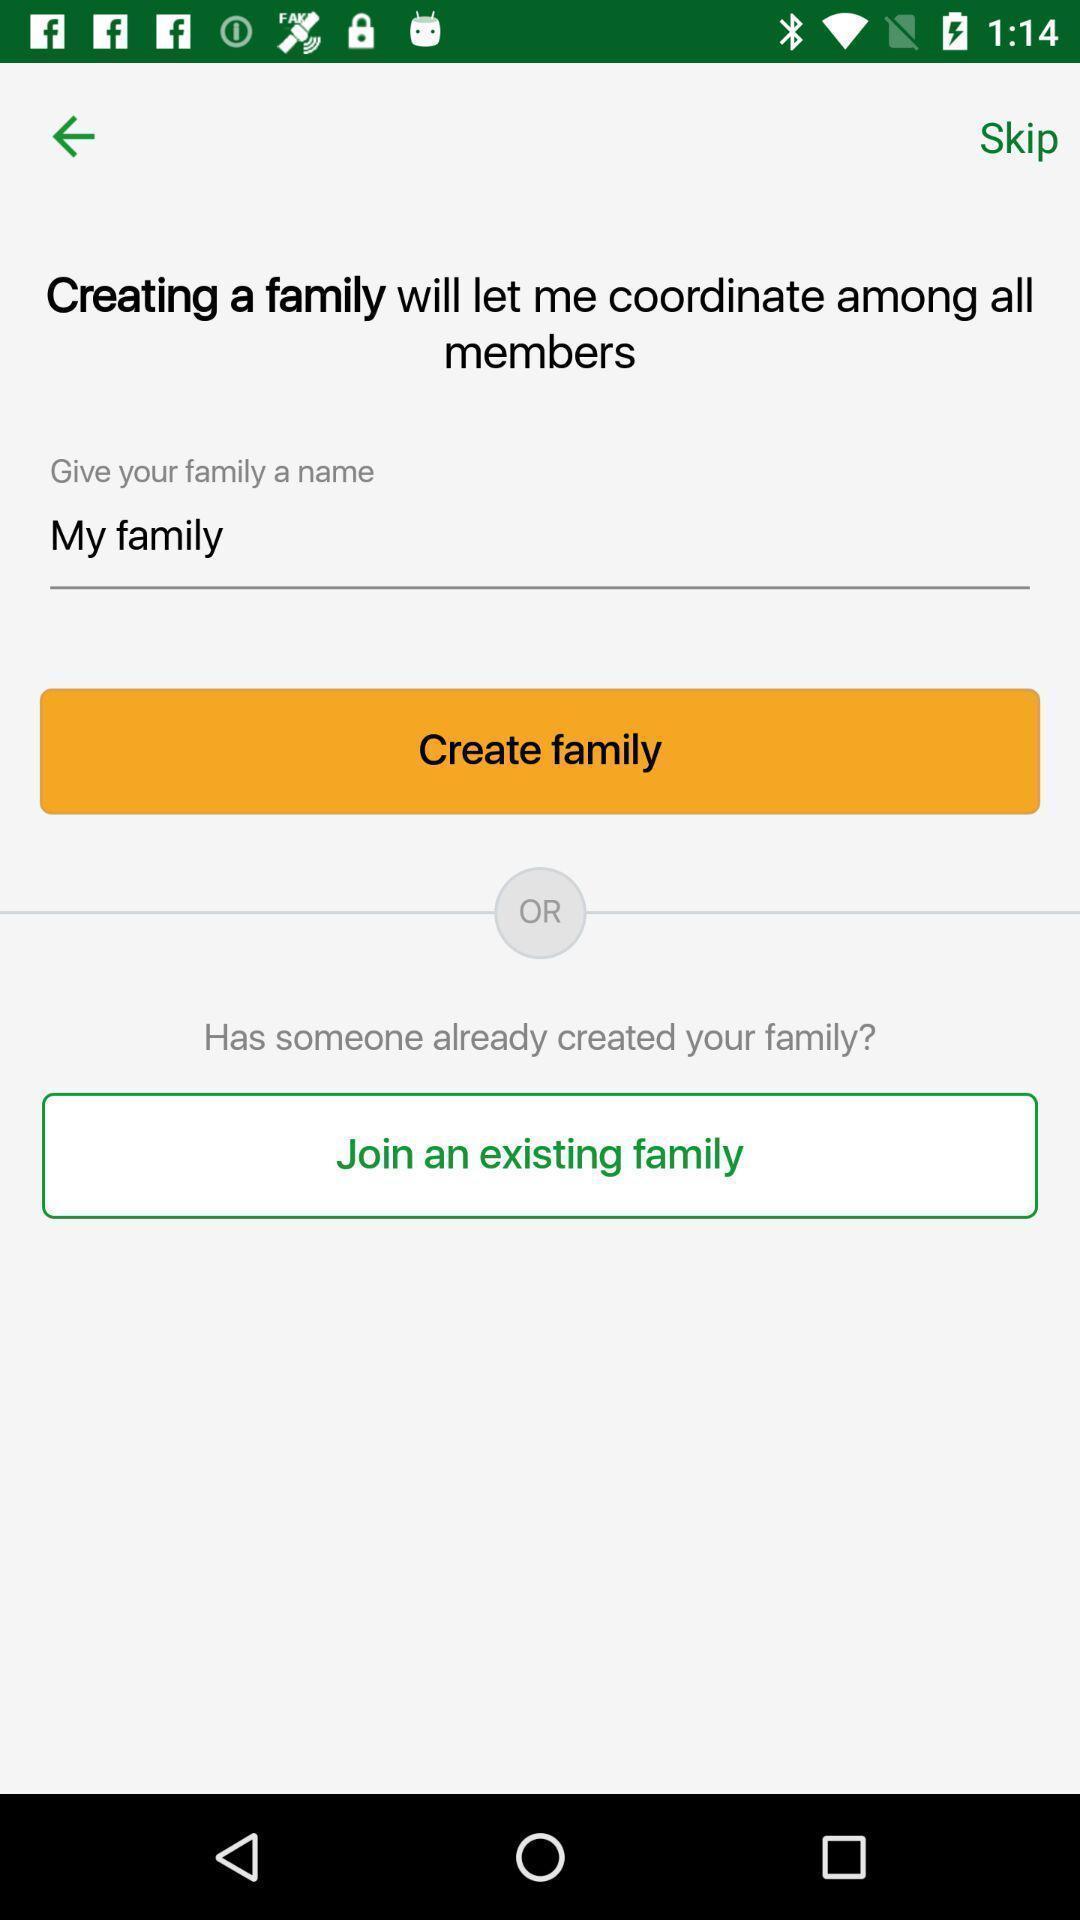Describe this image in words. Screen showing create family option. 